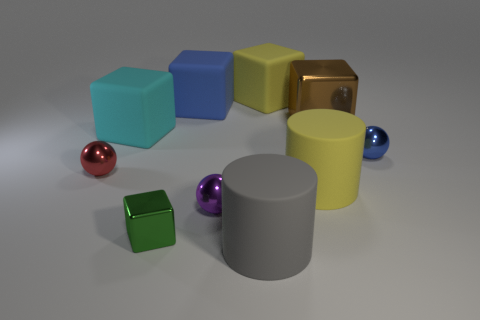How many other things are there of the same color as the big metal cube?
Offer a very short reply. 0. There is a small shiny object right of the rubber object that is in front of the tiny purple shiny sphere; what is its shape?
Your answer should be compact. Sphere. What number of tiny purple things are behind the big cyan matte cube?
Make the answer very short. 0. Are there any big yellow spheres that have the same material as the gray object?
Ensure brevity in your answer.  No. There is a purple thing that is the same size as the red metallic thing; what is it made of?
Your answer should be compact. Metal. There is a rubber object that is both behind the gray matte cylinder and in front of the red shiny ball; what size is it?
Provide a short and direct response. Large. What color is the big object that is in front of the large brown metallic object and behind the red sphere?
Offer a very short reply. Cyan. Are there fewer small metallic blocks that are behind the small green block than tiny purple spheres behind the blue matte block?
Provide a succinct answer. No. How many small purple shiny objects are the same shape as the tiny blue shiny object?
Offer a very short reply. 1. There is a red thing that is made of the same material as the large brown cube; what size is it?
Offer a very short reply. Small. 